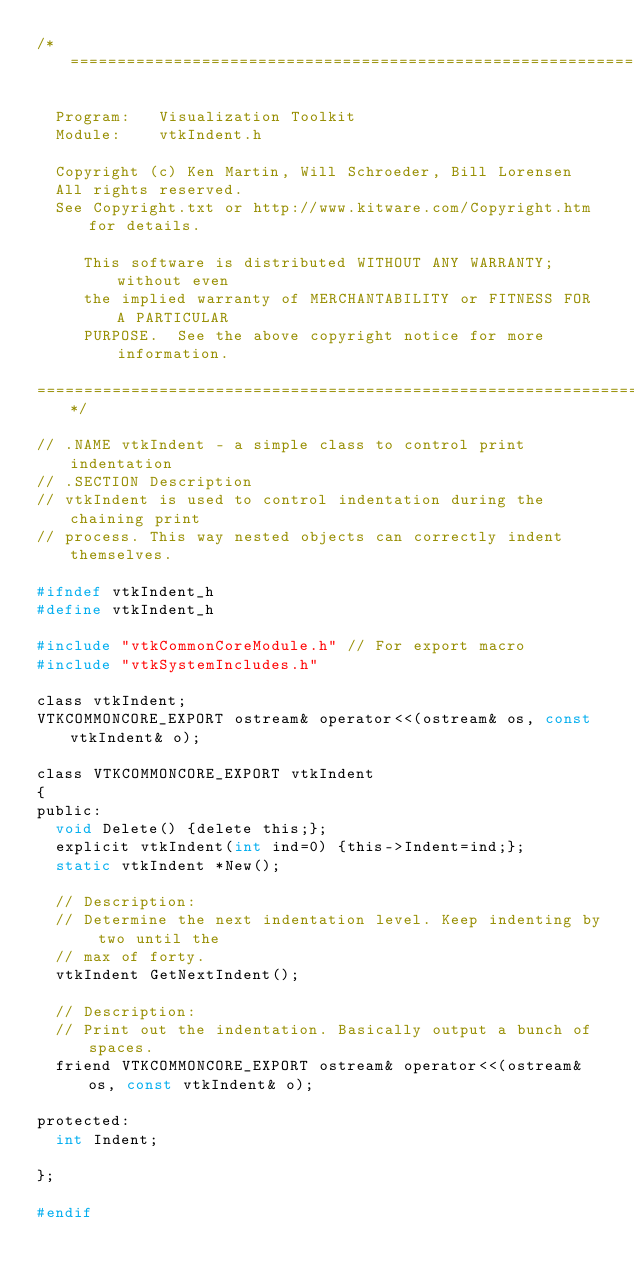<code> <loc_0><loc_0><loc_500><loc_500><_C_>/*=========================================================================

  Program:   Visualization Toolkit
  Module:    vtkIndent.h

  Copyright (c) Ken Martin, Will Schroeder, Bill Lorensen
  All rights reserved.
  See Copyright.txt or http://www.kitware.com/Copyright.htm for details.

     This software is distributed WITHOUT ANY WARRANTY; without even
     the implied warranty of MERCHANTABILITY or FITNESS FOR A PARTICULAR
     PURPOSE.  See the above copyright notice for more information.

=========================================================================*/

// .NAME vtkIndent - a simple class to control print indentation
// .SECTION Description
// vtkIndent is used to control indentation during the chaining print
// process. This way nested objects can correctly indent themselves.

#ifndef vtkIndent_h
#define vtkIndent_h

#include "vtkCommonCoreModule.h" // For export macro
#include "vtkSystemIncludes.h"

class vtkIndent;
VTKCOMMONCORE_EXPORT ostream& operator<<(ostream& os, const vtkIndent& o);

class VTKCOMMONCORE_EXPORT vtkIndent
{
public:
  void Delete() {delete this;};
  explicit vtkIndent(int ind=0) {this->Indent=ind;};
  static vtkIndent *New();

  // Description:
  // Determine the next indentation level. Keep indenting by two until the
  // max of forty.
  vtkIndent GetNextIndent();

  // Description:
  // Print out the indentation. Basically output a bunch of spaces.
  friend VTKCOMMONCORE_EXPORT ostream& operator<<(ostream& os, const vtkIndent& o);

protected:
  int Indent;

};

#endif</code> 